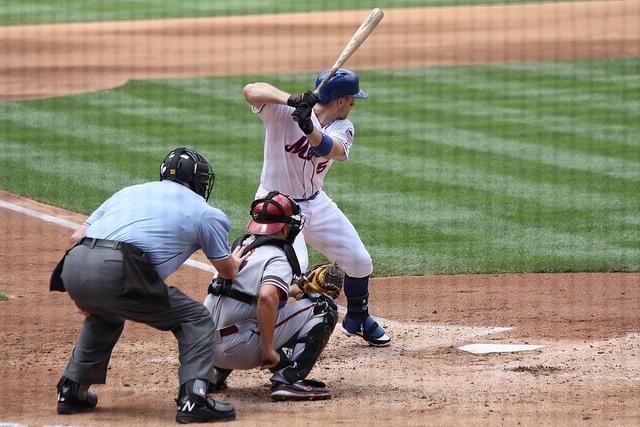What brand are the umpire's shoes?
Quick response, please. Nike. Is this a strike?
Be succinct. No. What sport is this?
Short answer required. Baseball. 